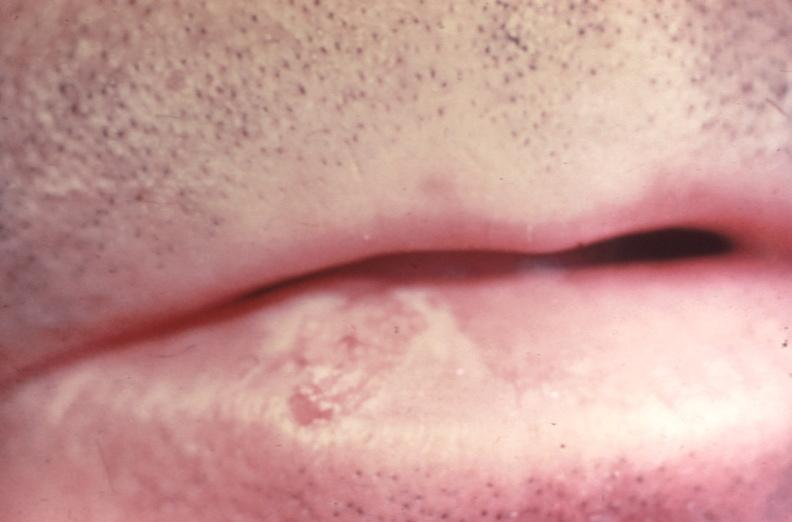what does this image show?
Answer the question using a single word or phrase. Squamous cell carcinoma 